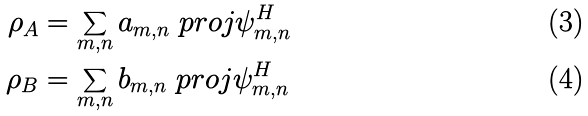<formula> <loc_0><loc_0><loc_500><loc_500>\rho _ { A } & = \sum _ { m , n } a _ { m , n } \ p r o j { \psi _ { m , n } ^ { H } } \\ \rho _ { B } & = \sum _ { m , n } b _ { m , n } \ p r o j { \psi _ { m , n } ^ { H } }</formula> 